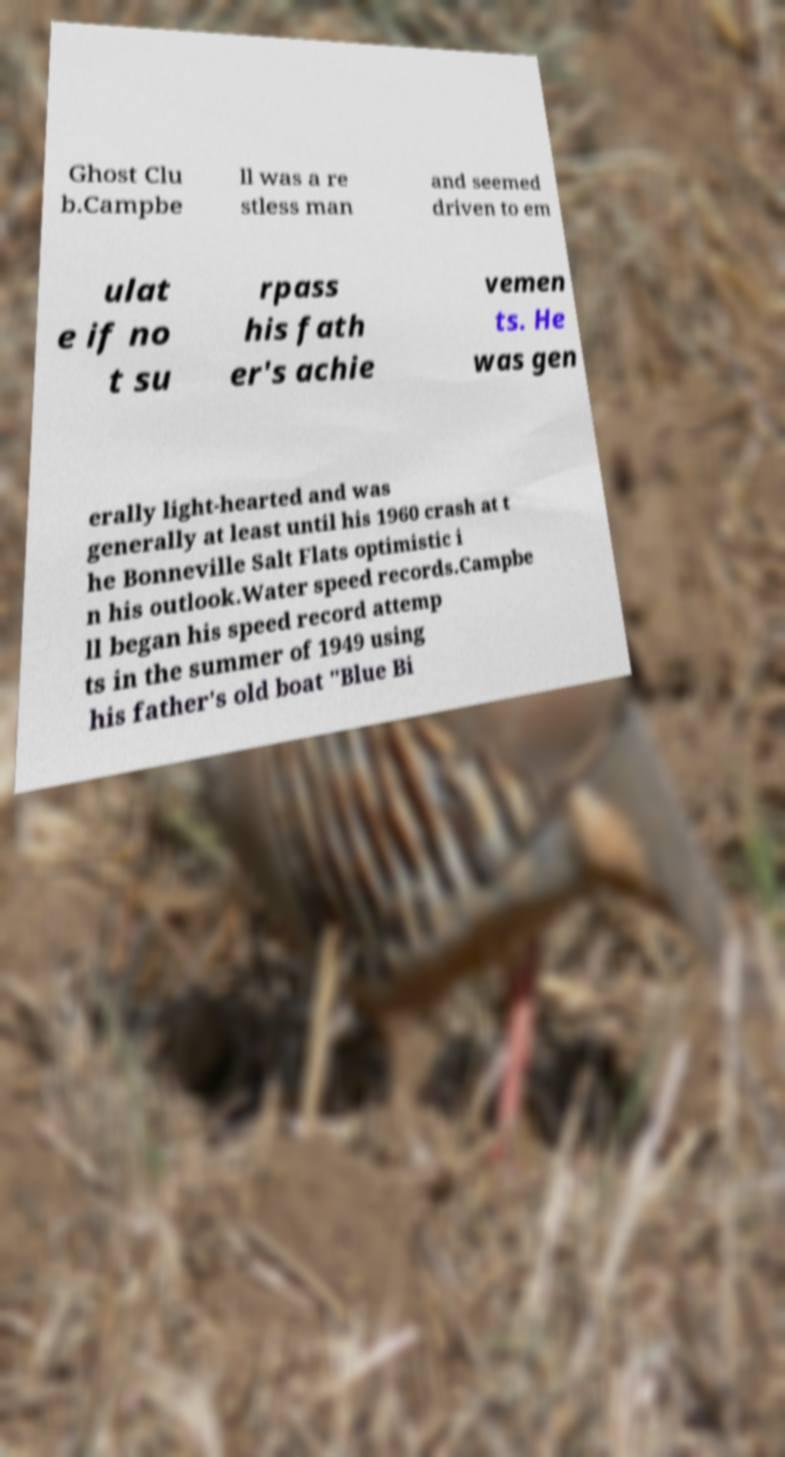Could you assist in decoding the text presented in this image and type it out clearly? Ghost Clu b.Campbe ll was a re stless man and seemed driven to em ulat e if no t su rpass his fath er's achie vemen ts. He was gen erally light-hearted and was generally at least until his 1960 crash at t he Bonneville Salt Flats optimistic i n his outlook.Water speed records.Campbe ll began his speed record attemp ts in the summer of 1949 using his father's old boat "Blue Bi 